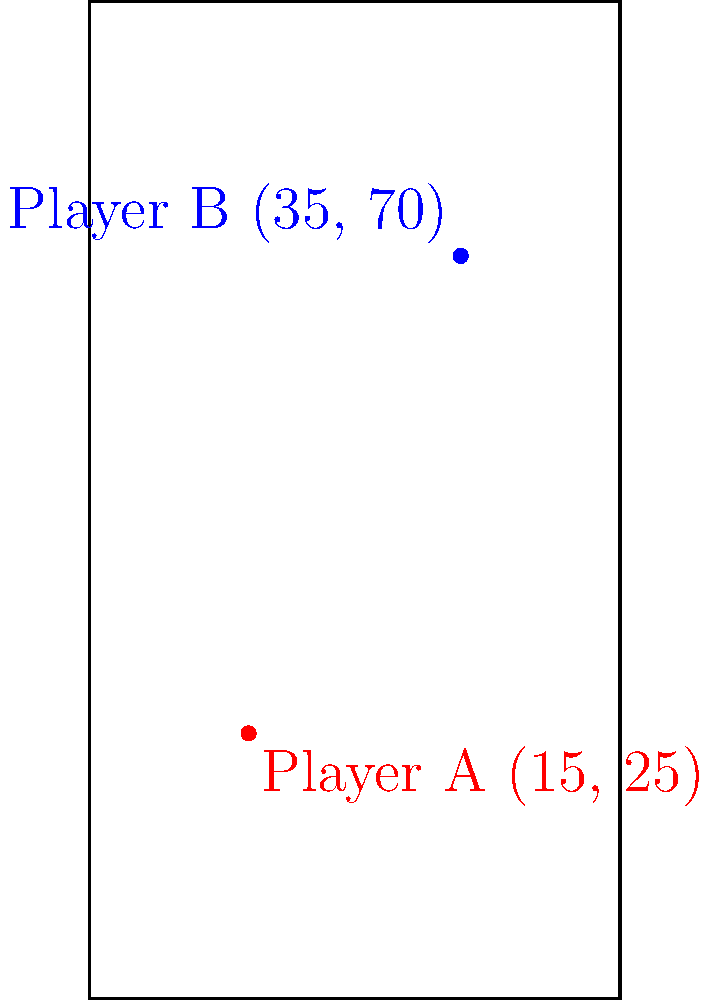During a Notre Dame home game, two players are positioned on the court as shown in the diagram. Player A is at coordinates (15, 25) and Player B is at coordinates (35, 70). Using the Cartesian coordinate system, calculate the straight-line distance between these two players. Round your answer to the nearest foot. To find the distance between two points in a Cartesian coordinate system, we can use the distance formula:

$$d = \sqrt{(x_2 - x_1)^2 + (y_2 - y_1)^2}$$

Where $(x_1, y_1)$ are the coordinates of Player A and $(x_2, y_2)$ are the coordinates of Player B.

Step 1: Identify the coordinates
Player A: $(x_1, y_1) = (15, 25)$
Player B: $(x_2, y_2) = (35, 70)$

Step 2: Plug the values into the distance formula
$$d = \sqrt{(35 - 15)^2 + (70 - 25)^2}$$

Step 3: Simplify the expressions inside the parentheses
$$d = \sqrt{(20)^2 + (45)^2}$$

Step 4: Calculate the squares
$$d = \sqrt{400 + 2025}$$

Step 5: Add the values under the square root
$$d = \sqrt{2425}$$

Step 6: Calculate the square root and round to the nearest foot
$$d \approx 49.24 \approx 49\text{ feet}$$

Therefore, the straight-line distance between Player A and Player B is approximately 49 feet.
Answer: 49 feet 